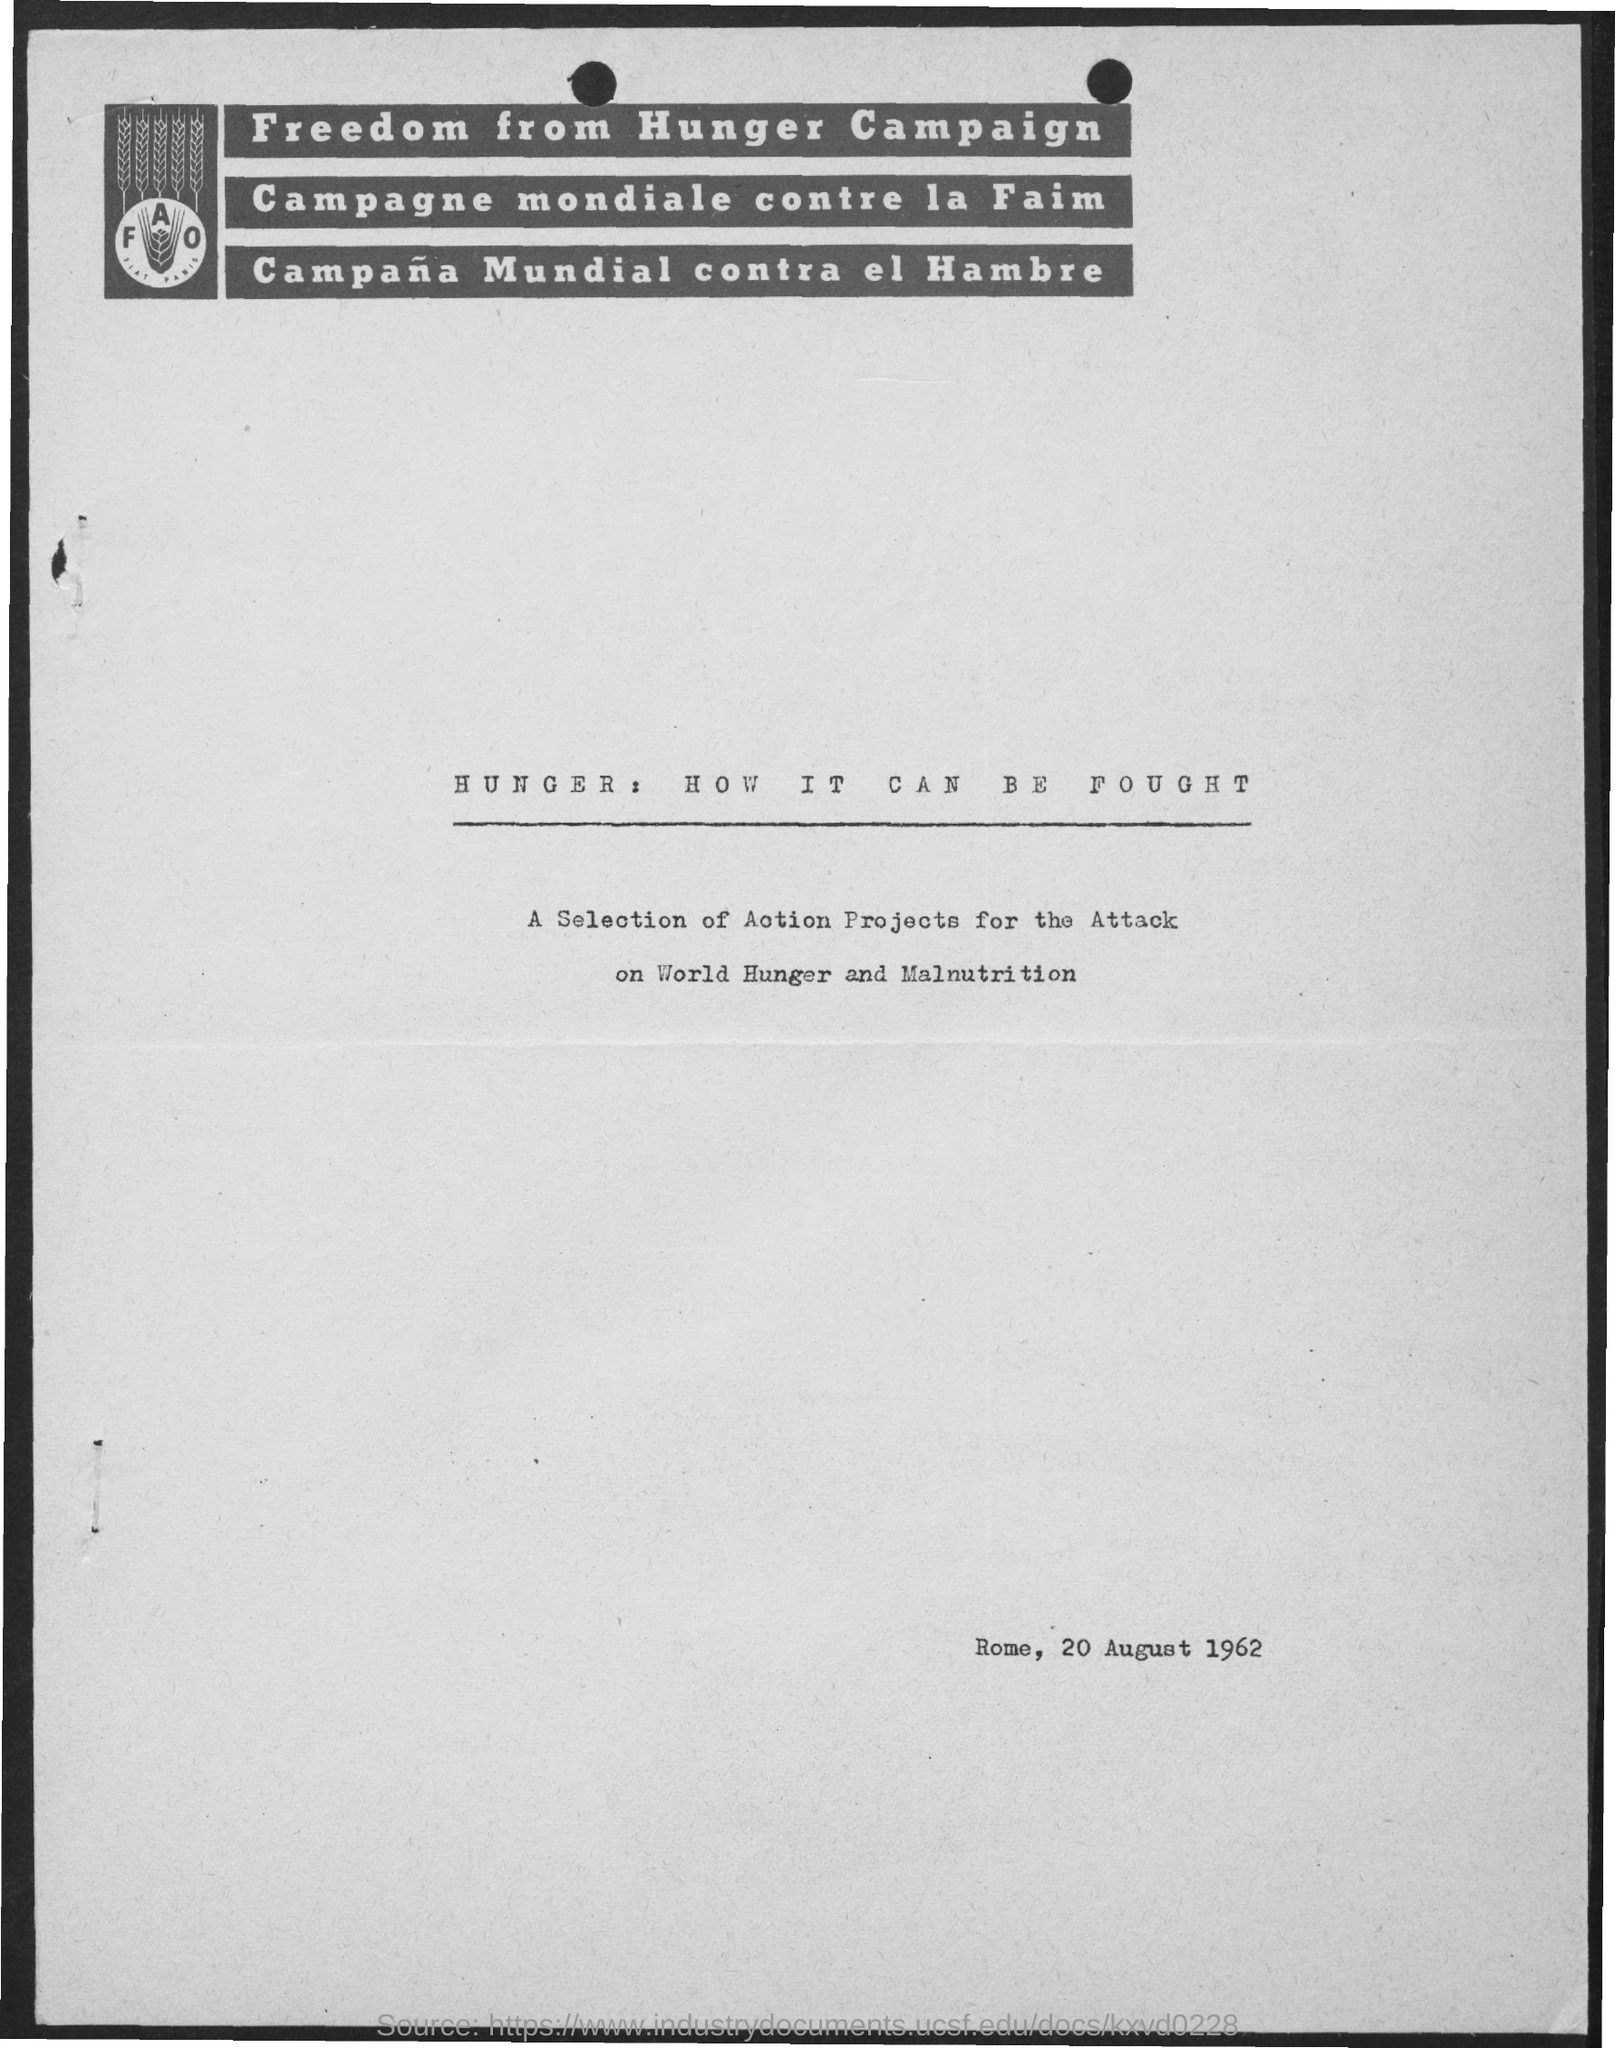What is the campaign about?
Offer a very short reply. Freedom from hunger campaign. When is the document dated?
Provide a succinct answer. 20 August 1962. 